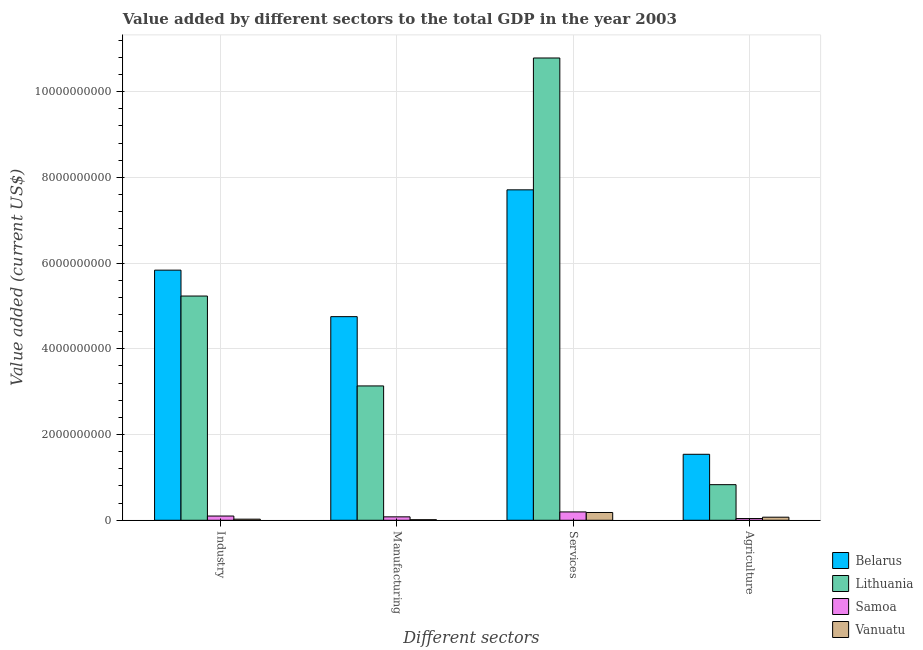How many different coloured bars are there?
Ensure brevity in your answer.  4. How many groups of bars are there?
Offer a very short reply. 4. Are the number of bars per tick equal to the number of legend labels?
Your response must be concise. Yes. Are the number of bars on each tick of the X-axis equal?
Provide a short and direct response. Yes. How many bars are there on the 2nd tick from the left?
Provide a succinct answer. 4. What is the label of the 2nd group of bars from the left?
Your answer should be very brief. Manufacturing. What is the value added by manufacturing sector in Belarus?
Offer a very short reply. 4.75e+09. Across all countries, what is the maximum value added by manufacturing sector?
Provide a succinct answer. 4.75e+09. Across all countries, what is the minimum value added by agricultural sector?
Ensure brevity in your answer.  4.04e+07. In which country was the value added by industrial sector maximum?
Keep it short and to the point. Belarus. In which country was the value added by manufacturing sector minimum?
Give a very brief answer. Vanuatu. What is the total value added by services sector in the graph?
Provide a succinct answer. 1.89e+1. What is the difference between the value added by manufacturing sector in Samoa and that in Belarus?
Your answer should be compact. -4.67e+09. What is the difference between the value added by industrial sector in Vanuatu and the value added by manufacturing sector in Samoa?
Give a very brief answer. -5.40e+07. What is the average value added by agricultural sector per country?
Provide a short and direct response. 6.21e+08. What is the difference between the value added by manufacturing sector and value added by services sector in Belarus?
Make the answer very short. -2.96e+09. What is the ratio of the value added by industrial sector in Samoa to that in Lithuania?
Your answer should be compact. 0.02. What is the difference between the highest and the second highest value added by agricultural sector?
Keep it short and to the point. 7.09e+08. What is the difference between the highest and the lowest value added by manufacturing sector?
Make the answer very short. 4.74e+09. In how many countries, is the value added by manufacturing sector greater than the average value added by manufacturing sector taken over all countries?
Offer a terse response. 2. Is it the case that in every country, the sum of the value added by manufacturing sector and value added by services sector is greater than the sum of value added by industrial sector and value added by agricultural sector?
Your answer should be compact. No. What does the 4th bar from the left in Services represents?
Your answer should be compact. Vanuatu. What does the 3rd bar from the right in Manufacturing represents?
Give a very brief answer. Lithuania. How many countries are there in the graph?
Keep it short and to the point. 4. What is the difference between two consecutive major ticks on the Y-axis?
Your answer should be very brief. 2.00e+09. Does the graph contain any zero values?
Make the answer very short. No. Does the graph contain grids?
Ensure brevity in your answer.  Yes. How many legend labels are there?
Give a very brief answer. 4. What is the title of the graph?
Keep it short and to the point. Value added by different sectors to the total GDP in the year 2003. Does "Ecuador" appear as one of the legend labels in the graph?
Your answer should be very brief. No. What is the label or title of the X-axis?
Provide a succinct answer. Different sectors. What is the label or title of the Y-axis?
Keep it short and to the point. Value added (current US$). What is the Value added (current US$) of Belarus in Industry?
Your answer should be compact. 5.84e+09. What is the Value added (current US$) in Lithuania in Industry?
Make the answer very short. 5.23e+09. What is the Value added (current US$) in Samoa in Industry?
Offer a very short reply. 9.86e+07. What is the Value added (current US$) in Vanuatu in Industry?
Ensure brevity in your answer.  2.58e+07. What is the Value added (current US$) in Belarus in Manufacturing?
Your answer should be compact. 4.75e+09. What is the Value added (current US$) of Lithuania in Manufacturing?
Keep it short and to the point. 3.13e+09. What is the Value added (current US$) of Samoa in Manufacturing?
Make the answer very short. 7.98e+07. What is the Value added (current US$) in Vanuatu in Manufacturing?
Offer a very short reply. 1.29e+07. What is the Value added (current US$) of Belarus in Services?
Offer a terse response. 7.71e+09. What is the Value added (current US$) in Lithuania in Services?
Offer a very short reply. 1.08e+1. What is the Value added (current US$) of Samoa in Services?
Keep it short and to the point. 1.94e+08. What is the Value added (current US$) in Vanuatu in Services?
Make the answer very short. 1.81e+08. What is the Value added (current US$) in Belarus in Agriculture?
Your answer should be compact. 1.54e+09. What is the Value added (current US$) of Lithuania in Agriculture?
Ensure brevity in your answer.  8.31e+08. What is the Value added (current US$) in Samoa in Agriculture?
Provide a short and direct response. 4.04e+07. What is the Value added (current US$) in Vanuatu in Agriculture?
Your answer should be very brief. 7.18e+07. Across all Different sectors, what is the maximum Value added (current US$) in Belarus?
Keep it short and to the point. 7.71e+09. Across all Different sectors, what is the maximum Value added (current US$) in Lithuania?
Offer a terse response. 1.08e+1. Across all Different sectors, what is the maximum Value added (current US$) of Samoa?
Your answer should be very brief. 1.94e+08. Across all Different sectors, what is the maximum Value added (current US$) of Vanuatu?
Provide a succinct answer. 1.81e+08. Across all Different sectors, what is the minimum Value added (current US$) of Belarus?
Your answer should be very brief. 1.54e+09. Across all Different sectors, what is the minimum Value added (current US$) in Lithuania?
Offer a very short reply. 8.31e+08. Across all Different sectors, what is the minimum Value added (current US$) in Samoa?
Make the answer very short. 4.04e+07. Across all Different sectors, what is the minimum Value added (current US$) in Vanuatu?
Give a very brief answer. 1.29e+07. What is the total Value added (current US$) of Belarus in the graph?
Ensure brevity in your answer.  1.98e+1. What is the total Value added (current US$) of Lithuania in the graph?
Your answer should be compact. 2.00e+1. What is the total Value added (current US$) in Samoa in the graph?
Give a very brief answer. 4.13e+08. What is the total Value added (current US$) of Vanuatu in the graph?
Offer a terse response. 2.92e+08. What is the difference between the Value added (current US$) in Belarus in Industry and that in Manufacturing?
Make the answer very short. 1.09e+09. What is the difference between the Value added (current US$) of Lithuania in Industry and that in Manufacturing?
Your answer should be very brief. 2.10e+09. What is the difference between the Value added (current US$) in Samoa in Industry and that in Manufacturing?
Your response must be concise. 1.89e+07. What is the difference between the Value added (current US$) in Vanuatu in Industry and that in Manufacturing?
Ensure brevity in your answer.  1.29e+07. What is the difference between the Value added (current US$) of Belarus in Industry and that in Services?
Your response must be concise. -1.87e+09. What is the difference between the Value added (current US$) in Lithuania in Industry and that in Services?
Your answer should be very brief. -5.55e+09. What is the difference between the Value added (current US$) of Samoa in Industry and that in Services?
Your response must be concise. -9.58e+07. What is the difference between the Value added (current US$) of Vanuatu in Industry and that in Services?
Give a very brief answer. -1.56e+08. What is the difference between the Value added (current US$) of Belarus in Industry and that in Agriculture?
Make the answer very short. 4.30e+09. What is the difference between the Value added (current US$) of Lithuania in Industry and that in Agriculture?
Your response must be concise. 4.40e+09. What is the difference between the Value added (current US$) in Samoa in Industry and that in Agriculture?
Your answer should be compact. 5.82e+07. What is the difference between the Value added (current US$) in Vanuatu in Industry and that in Agriculture?
Ensure brevity in your answer.  -4.60e+07. What is the difference between the Value added (current US$) of Belarus in Manufacturing and that in Services?
Your response must be concise. -2.96e+09. What is the difference between the Value added (current US$) in Lithuania in Manufacturing and that in Services?
Offer a terse response. -7.65e+09. What is the difference between the Value added (current US$) in Samoa in Manufacturing and that in Services?
Your answer should be very brief. -1.15e+08. What is the difference between the Value added (current US$) of Vanuatu in Manufacturing and that in Services?
Offer a very short reply. -1.68e+08. What is the difference between the Value added (current US$) of Belarus in Manufacturing and that in Agriculture?
Your answer should be very brief. 3.21e+09. What is the difference between the Value added (current US$) in Lithuania in Manufacturing and that in Agriculture?
Provide a short and direct response. 2.30e+09. What is the difference between the Value added (current US$) in Samoa in Manufacturing and that in Agriculture?
Your response must be concise. 3.93e+07. What is the difference between the Value added (current US$) in Vanuatu in Manufacturing and that in Agriculture?
Provide a succinct answer. -5.89e+07. What is the difference between the Value added (current US$) of Belarus in Services and that in Agriculture?
Your answer should be compact. 6.17e+09. What is the difference between the Value added (current US$) in Lithuania in Services and that in Agriculture?
Provide a succinct answer. 9.96e+09. What is the difference between the Value added (current US$) of Samoa in Services and that in Agriculture?
Keep it short and to the point. 1.54e+08. What is the difference between the Value added (current US$) in Vanuatu in Services and that in Agriculture?
Provide a succinct answer. 1.10e+08. What is the difference between the Value added (current US$) of Belarus in Industry and the Value added (current US$) of Lithuania in Manufacturing?
Give a very brief answer. 2.70e+09. What is the difference between the Value added (current US$) in Belarus in Industry and the Value added (current US$) in Samoa in Manufacturing?
Offer a terse response. 5.76e+09. What is the difference between the Value added (current US$) of Belarus in Industry and the Value added (current US$) of Vanuatu in Manufacturing?
Your answer should be compact. 5.82e+09. What is the difference between the Value added (current US$) in Lithuania in Industry and the Value added (current US$) in Samoa in Manufacturing?
Your answer should be compact. 5.15e+09. What is the difference between the Value added (current US$) in Lithuania in Industry and the Value added (current US$) in Vanuatu in Manufacturing?
Give a very brief answer. 5.22e+09. What is the difference between the Value added (current US$) in Samoa in Industry and the Value added (current US$) in Vanuatu in Manufacturing?
Give a very brief answer. 8.57e+07. What is the difference between the Value added (current US$) of Belarus in Industry and the Value added (current US$) of Lithuania in Services?
Make the answer very short. -4.95e+09. What is the difference between the Value added (current US$) in Belarus in Industry and the Value added (current US$) in Samoa in Services?
Give a very brief answer. 5.64e+09. What is the difference between the Value added (current US$) in Belarus in Industry and the Value added (current US$) in Vanuatu in Services?
Your answer should be compact. 5.65e+09. What is the difference between the Value added (current US$) in Lithuania in Industry and the Value added (current US$) in Samoa in Services?
Your response must be concise. 5.04e+09. What is the difference between the Value added (current US$) in Lithuania in Industry and the Value added (current US$) in Vanuatu in Services?
Give a very brief answer. 5.05e+09. What is the difference between the Value added (current US$) of Samoa in Industry and the Value added (current US$) of Vanuatu in Services?
Ensure brevity in your answer.  -8.27e+07. What is the difference between the Value added (current US$) of Belarus in Industry and the Value added (current US$) of Lithuania in Agriculture?
Your response must be concise. 5.01e+09. What is the difference between the Value added (current US$) in Belarus in Industry and the Value added (current US$) in Samoa in Agriculture?
Offer a very short reply. 5.80e+09. What is the difference between the Value added (current US$) of Belarus in Industry and the Value added (current US$) of Vanuatu in Agriculture?
Offer a terse response. 5.76e+09. What is the difference between the Value added (current US$) of Lithuania in Industry and the Value added (current US$) of Samoa in Agriculture?
Provide a short and direct response. 5.19e+09. What is the difference between the Value added (current US$) in Lithuania in Industry and the Value added (current US$) in Vanuatu in Agriculture?
Your answer should be compact. 5.16e+09. What is the difference between the Value added (current US$) in Samoa in Industry and the Value added (current US$) in Vanuatu in Agriculture?
Offer a very short reply. 2.68e+07. What is the difference between the Value added (current US$) in Belarus in Manufacturing and the Value added (current US$) in Lithuania in Services?
Your answer should be compact. -6.04e+09. What is the difference between the Value added (current US$) of Belarus in Manufacturing and the Value added (current US$) of Samoa in Services?
Make the answer very short. 4.56e+09. What is the difference between the Value added (current US$) in Belarus in Manufacturing and the Value added (current US$) in Vanuatu in Services?
Provide a short and direct response. 4.57e+09. What is the difference between the Value added (current US$) in Lithuania in Manufacturing and the Value added (current US$) in Samoa in Services?
Make the answer very short. 2.94e+09. What is the difference between the Value added (current US$) of Lithuania in Manufacturing and the Value added (current US$) of Vanuatu in Services?
Provide a succinct answer. 2.95e+09. What is the difference between the Value added (current US$) of Samoa in Manufacturing and the Value added (current US$) of Vanuatu in Services?
Give a very brief answer. -1.02e+08. What is the difference between the Value added (current US$) of Belarus in Manufacturing and the Value added (current US$) of Lithuania in Agriculture?
Offer a terse response. 3.92e+09. What is the difference between the Value added (current US$) of Belarus in Manufacturing and the Value added (current US$) of Samoa in Agriculture?
Your answer should be very brief. 4.71e+09. What is the difference between the Value added (current US$) of Belarus in Manufacturing and the Value added (current US$) of Vanuatu in Agriculture?
Your answer should be very brief. 4.68e+09. What is the difference between the Value added (current US$) in Lithuania in Manufacturing and the Value added (current US$) in Samoa in Agriculture?
Keep it short and to the point. 3.09e+09. What is the difference between the Value added (current US$) in Lithuania in Manufacturing and the Value added (current US$) in Vanuatu in Agriculture?
Give a very brief answer. 3.06e+09. What is the difference between the Value added (current US$) in Samoa in Manufacturing and the Value added (current US$) in Vanuatu in Agriculture?
Offer a very short reply. 7.96e+06. What is the difference between the Value added (current US$) in Belarus in Services and the Value added (current US$) in Lithuania in Agriculture?
Provide a succinct answer. 6.88e+09. What is the difference between the Value added (current US$) in Belarus in Services and the Value added (current US$) in Samoa in Agriculture?
Offer a very short reply. 7.67e+09. What is the difference between the Value added (current US$) in Belarus in Services and the Value added (current US$) in Vanuatu in Agriculture?
Offer a very short reply. 7.64e+09. What is the difference between the Value added (current US$) of Lithuania in Services and the Value added (current US$) of Samoa in Agriculture?
Ensure brevity in your answer.  1.07e+1. What is the difference between the Value added (current US$) in Lithuania in Services and the Value added (current US$) in Vanuatu in Agriculture?
Your answer should be very brief. 1.07e+1. What is the difference between the Value added (current US$) of Samoa in Services and the Value added (current US$) of Vanuatu in Agriculture?
Provide a short and direct response. 1.23e+08. What is the average Value added (current US$) of Belarus per Different sectors?
Your answer should be very brief. 4.96e+09. What is the average Value added (current US$) in Lithuania per Different sectors?
Provide a short and direct response. 5.00e+09. What is the average Value added (current US$) in Samoa per Different sectors?
Keep it short and to the point. 1.03e+08. What is the average Value added (current US$) of Vanuatu per Different sectors?
Your response must be concise. 7.29e+07. What is the difference between the Value added (current US$) of Belarus and Value added (current US$) of Lithuania in Industry?
Your response must be concise. 6.04e+08. What is the difference between the Value added (current US$) in Belarus and Value added (current US$) in Samoa in Industry?
Provide a succinct answer. 5.74e+09. What is the difference between the Value added (current US$) in Belarus and Value added (current US$) in Vanuatu in Industry?
Make the answer very short. 5.81e+09. What is the difference between the Value added (current US$) of Lithuania and Value added (current US$) of Samoa in Industry?
Your answer should be very brief. 5.13e+09. What is the difference between the Value added (current US$) of Lithuania and Value added (current US$) of Vanuatu in Industry?
Keep it short and to the point. 5.21e+09. What is the difference between the Value added (current US$) of Samoa and Value added (current US$) of Vanuatu in Industry?
Offer a very short reply. 7.29e+07. What is the difference between the Value added (current US$) of Belarus and Value added (current US$) of Lithuania in Manufacturing?
Offer a very short reply. 1.62e+09. What is the difference between the Value added (current US$) in Belarus and Value added (current US$) in Samoa in Manufacturing?
Your answer should be compact. 4.67e+09. What is the difference between the Value added (current US$) in Belarus and Value added (current US$) in Vanuatu in Manufacturing?
Offer a terse response. 4.74e+09. What is the difference between the Value added (current US$) of Lithuania and Value added (current US$) of Samoa in Manufacturing?
Give a very brief answer. 3.05e+09. What is the difference between the Value added (current US$) of Lithuania and Value added (current US$) of Vanuatu in Manufacturing?
Keep it short and to the point. 3.12e+09. What is the difference between the Value added (current US$) of Samoa and Value added (current US$) of Vanuatu in Manufacturing?
Offer a very short reply. 6.68e+07. What is the difference between the Value added (current US$) in Belarus and Value added (current US$) in Lithuania in Services?
Offer a terse response. -3.08e+09. What is the difference between the Value added (current US$) in Belarus and Value added (current US$) in Samoa in Services?
Provide a succinct answer. 7.52e+09. What is the difference between the Value added (current US$) of Belarus and Value added (current US$) of Vanuatu in Services?
Your response must be concise. 7.53e+09. What is the difference between the Value added (current US$) of Lithuania and Value added (current US$) of Samoa in Services?
Provide a short and direct response. 1.06e+1. What is the difference between the Value added (current US$) in Lithuania and Value added (current US$) in Vanuatu in Services?
Provide a succinct answer. 1.06e+1. What is the difference between the Value added (current US$) in Samoa and Value added (current US$) in Vanuatu in Services?
Provide a succinct answer. 1.31e+07. What is the difference between the Value added (current US$) of Belarus and Value added (current US$) of Lithuania in Agriculture?
Offer a very short reply. 7.09e+08. What is the difference between the Value added (current US$) in Belarus and Value added (current US$) in Samoa in Agriculture?
Keep it short and to the point. 1.50e+09. What is the difference between the Value added (current US$) of Belarus and Value added (current US$) of Vanuatu in Agriculture?
Your response must be concise. 1.47e+09. What is the difference between the Value added (current US$) in Lithuania and Value added (current US$) in Samoa in Agriculture?
Provide a short and direct response. 7.90e+08. What is the difference between the Value added (current US$) in Lithuania and Value added (current US$) in Vanuatu in Agriculture?
Ensure brevity in your answer.  7.59e+08. What is the difference between the Value added (current US$) of Samoa and Value added (current US$) of Vanuatu in Agriculture?
Provide a succinct answer. -3.14e+07. What is the ratio of the Value added (current US$) in Belarus in Industry to that in Manufacturing?
Make the answer very short. 1.23. What is the ratio of the Value added (current US$) in Lithuania in Industry to that in Manufacturing?
Offer a very short reply. 1.67. What is the ratio of the Value added (current US$) of Samoa in Industry to that in Manufacturing?
Keep it short and to the point. 1.24. What is the ratio of the Value added (current US$) in Vanuatu in Industry to that in Manufacturing?
Your answer should be compact. 2. What is the ratio of the Value added (current US$) of Belarus in Industry to that in Services?
Your answer should be very brief. 0.76. What is the ratio of the Value added (current US$) in Lithuania in Industry to that in Services?
Provide a succinct answer. 0.49. What is the ratio of the Value added (current US$) of Samoa in Industry to that in Services?
Ensure brevity in your answer.  0.51. What is the ratio of the Value added (current US$) in Vanuatu in Industry to that in Services?
Keep it short and to the point. 0.14. What is the ratio of the Value added (current US$) of Belarus in Industry to that in Agriculture?
Your answer should be compact. 3.79. What is the ratio of the Value added (current US$) in Lithuania in Industry to that in Agriculture?
Offer a terse response. 6.3. What is the ratio of the Value added (current US$) of Samoa in Industry to that in Agriculture?
Offer a very short reply. 2.44. What is the ratio of the Value added (current US$) of Vanuatu in Industry to that in Agriculture?
Make the answer very short. 0.36. What is the ratio of the Value added (current US$) in Belarus in Manufacturing to that in Services?
Offer a terse response. 0.62. What is the ratio of the Value added (current US$) of Lithuania in Manufacturing to that in Services?
Offer a terse response. 0.29. What is the ratio of the Value added (current US$) in Samoa in Manufacturing to that in Services?
Offer a very short reply. 0.41. What is the ratio of the Value added (current US$) in Vanuatu in Manufacturing to that in Services?
Ensure brevity in your answer.  0.07. What is the ratio of the Value added (current US$) in Belarus in Manufacturing to that in Agriculture?
Offer a terse response. 3.09. What is the ratio of the Value added (current US$) in Lithuania in Manufacturing to that in Agriculture?
Ensure brevity in your answer.  3.77. What is the ratio of the Value added (current US$) in Samoa in Manufacturing to that in Agriculture?
Your answer should be very brief. 1.97. What is the ratio of the Value added (current US$) in Vanuatu in Manufacturing to that in Agriculture?
Your response must be concise. 0.18. What is the ratio of the Value added (current US$) of Belarus in Services to that in Agriculture?
Ensure brevity in your answer.  5.01. What is the ratio of the Value added (current US$) of Lithuania in Services to that in Agriculture?
Your response must be concise. 12.99. What is the ratio of the Value added (current US$) in Samoa in Services to that in Agriculture?
Give a very brief answer. 4.81. What is the ratio of the Value added (current US$) of Vanuatu in Services to that in Agriculture?
Give a very brief answer. 2.53. What is the difference between the highest and the second highest Value added (current US$) of Belarus?
Your answer should be very brief. 1.87e+09. What is the difference between the highest and the second highest Value added (current US$) of Lithuania?
Offer a terse response. 5.55e+09. What is the difference between the highest and the second highest Value added (current US$) of Samoa?
Keep it short and to the point. 9.58e+07. What is the difference between the highest and the second highest Value added (current US$) in Vanuatu?
Your answer should be very brief. 1.10e+08. What is the difference between the highest and the lowest Value added (current US$) of Belarus?
Offer a terse response. 6.17e+09. What is the difference between the highest and the lowest Value added (current US$) of Lithuania?
Offer a terse response. 9.96e+09. What is the difference between the highest and the lowest Value added (current US$) of Samoa?
Your answer should be very brief. 1.54e+08. What is the difference between the highest and the lowest Value added (current US$) in Vanuatu?
Offer a terse response. 1.68e+08. 